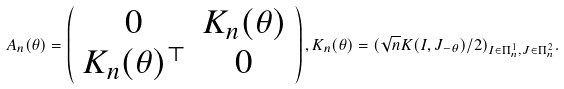Convert formula to latex. <formula><loc_0><loc_0><loc_500><loc_500>A _ { n } ( \theta ) = \left ( \begin{array} { c c } 0 & K _ { n } ( \theta ) \\ K _ { n } ( \theta ) ^ { \top } & 0 \end{array} \right ) , K _ { n } ( \theta ) = ( \sqrt { n } K ( I , J _ { - \theta } ) / 2 ) _ { I \in \Pi ^ { 1 } _ { n } , J \in \Pi ^ { 2 } _ { n } } .</formula> 